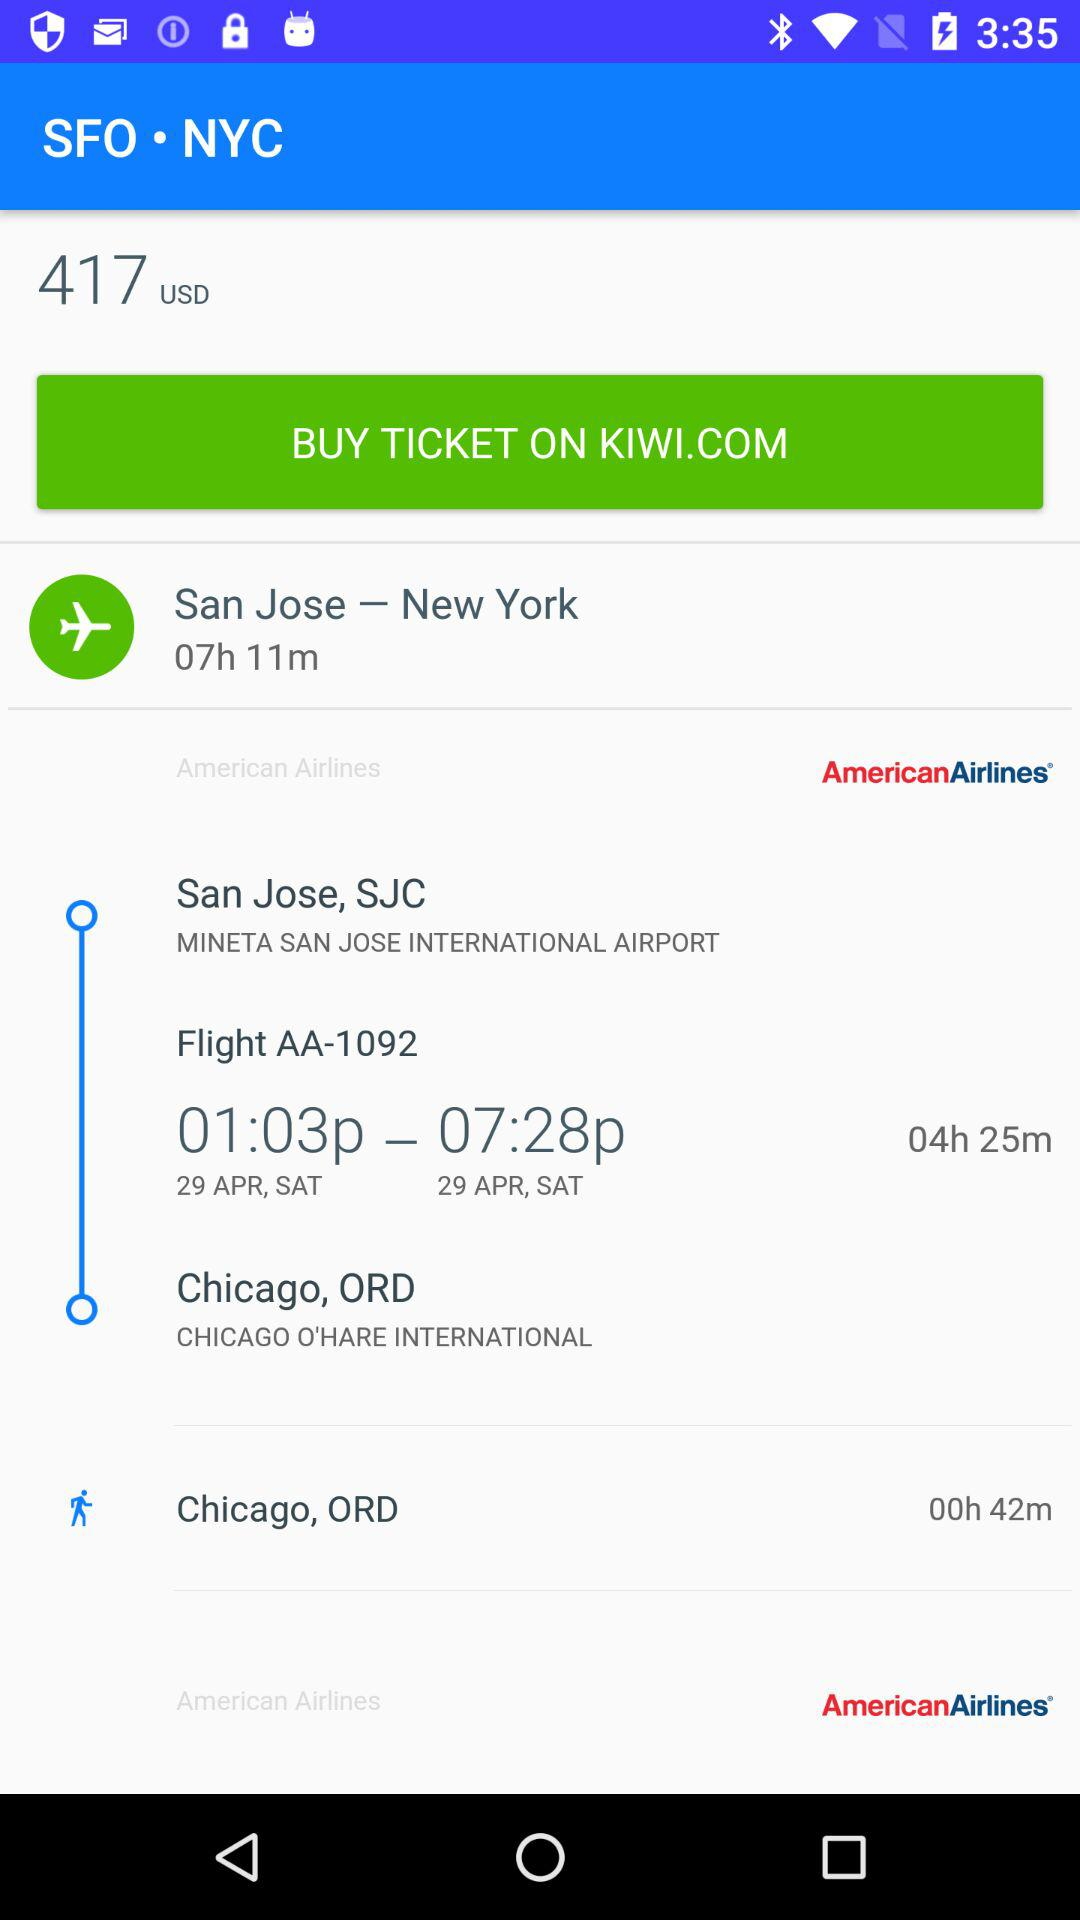What is the departure city name? The departure city name is San Jose. 